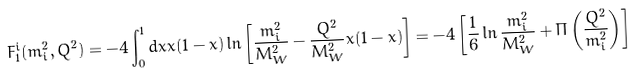<formula> <loc_0><loc_0><loc_500><loc_500>F _ { 1 } ^ { i } ( m _ { i } ^ { 2 } , Q ^ { 2 } ) = - 4 \int _ { 0 } ^ { 1 } d x x ( 1 - x ) \ln \left [ \frac { m _ { i } ^ { 2 } } { M _ { W } ^ { 2 } } - \frac { Q ^ { 2 } } { M _ { W } ^ { 2 } } x ( 1 - x ) \right ] = - 4 \left [ \frac { 1 } { 6 } \ln \frac { m _ { i } ^ { 2 } } { M _ { W } ^ { 2 } } + \Pi \left ( \frac { Q ^ { 2 } } { m _ { i } ^ { 2 } } \right ) \right ]</formula> 